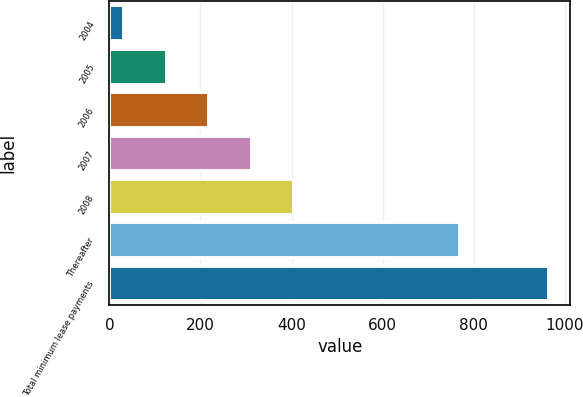Convert chart. <chart><loc_0><loc_0><loc_500><loc_500><bar_chart><fcel>2004<fcel>2005<fcel>2006<fcel>2007<fcel>2008<fcel>Thereafter<fcel>Total minimum lease payments<nl><fcel>31<fcel>124.3<fcel>217.6<fcel>310.9<fcel>404.2<fcel>768<fcel>964<nl></chart> 